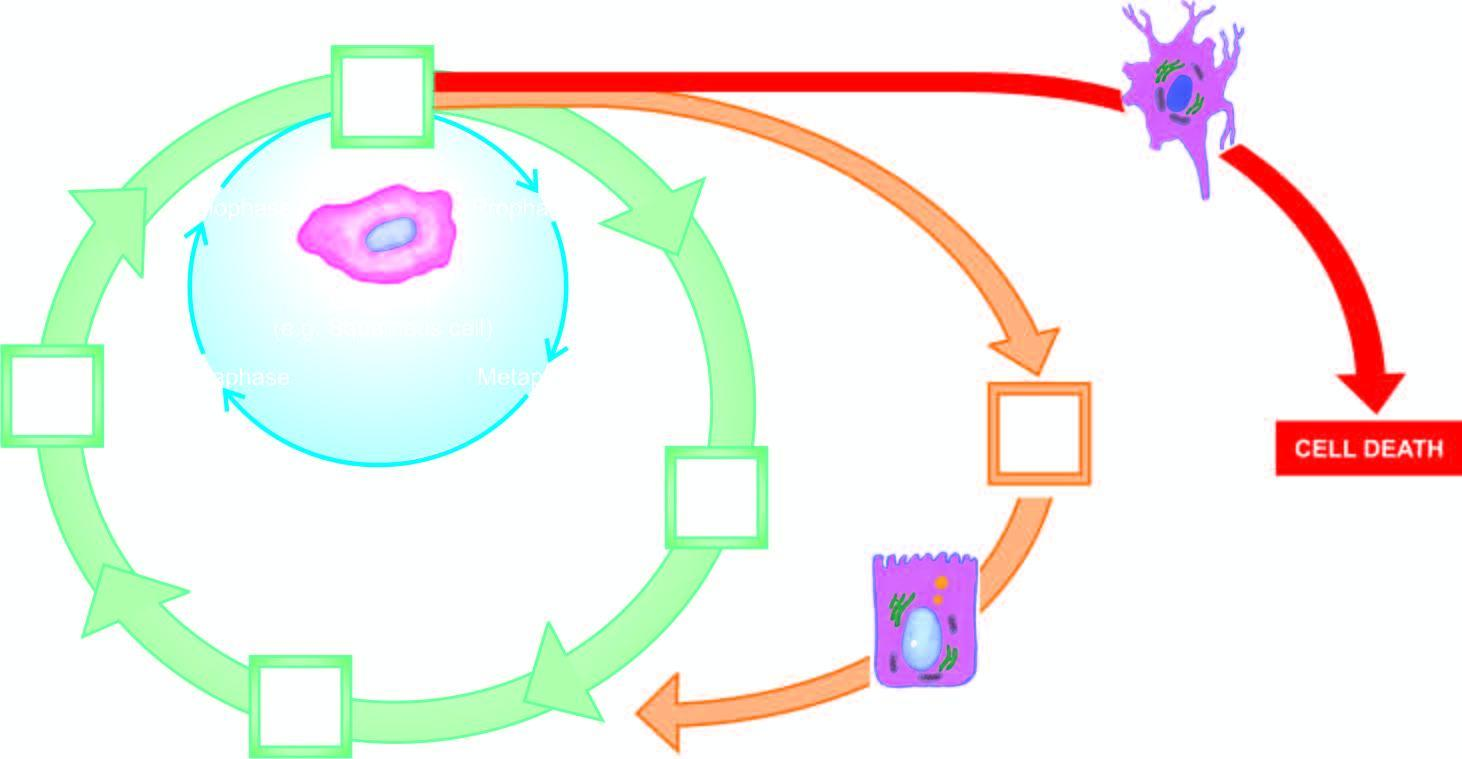what represents cell cycle for labile cells?
Answer the question using a single word or phrase. The particle 